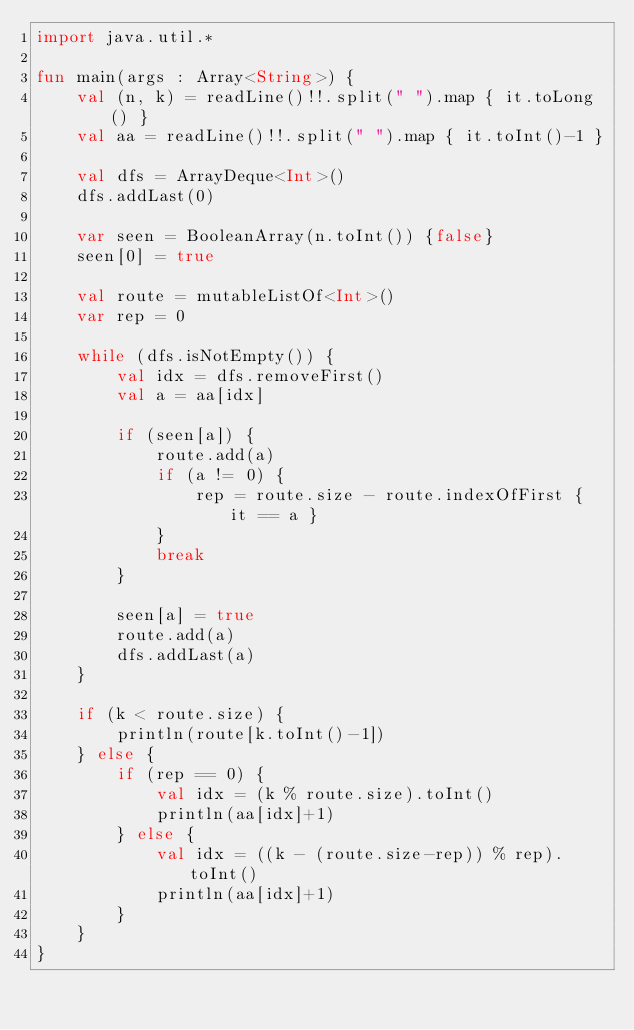Convert code to text. <code><loc_0><loc_0><loc_500><loc_500><_Kotlin_>import java.util.*

fun main(args : Array<String>) {
    val (n, k) = readLine()!!.split(" ").map { it.toLong() }
    val aa = readLine()!!.split(" ").map { it.toInt()-1 }

    val dfs = ArrayDeque<Int>()
    dfs.addLast(0)

    var seen = BooleanArray(n.toInt()) {false}
    seen[0] = true

    val route = mutableListOf<Int>()
    var rep = 0

    while (dfs.isNotEmpty()) {
        val idx = dfs.removeFirst()
        val a = aa[idx]

        if (seen[a]) {
            route.add(a)
            if (a != 0) {
                rep = route.size - route.indexOfFirst { it == a }
            }
            break
        }

        seen[a] = true
        route.add(a)
        dfs.addLast(a)
    }

    if (k < route.size) {
        println(route[k.toInt()-1])
    } else {
        if (rep == 0) {
            val idx = (k % route.size).toInt()
            println(aa[idx]+1)
        } else {
            val idx = ((k - (route.size-rep)) % rep).toInt()
            println(aa[idx]+1)
        }
    }
}</code> 